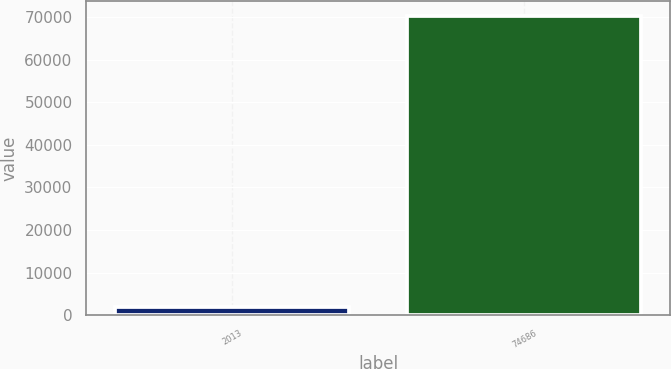Convert chart to OTSL. <chart><loc_0><loc_0><loc_500><loc_500><bar_chart><fcel>2013<fcel>74686<nl><fcel>2012<fcel>70211<nl></chart> 